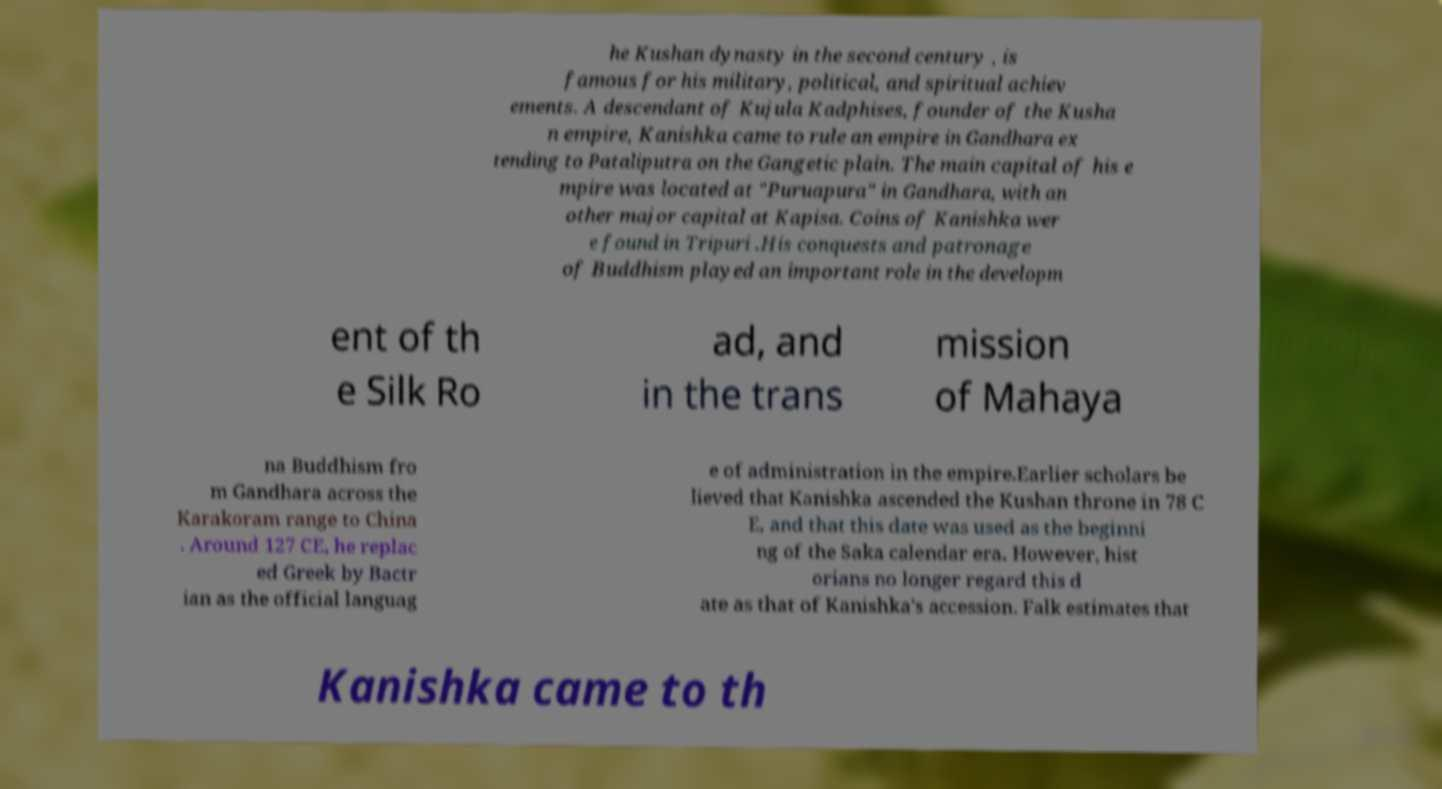Could you assist in decoding the text presented in this image and type it out clearly? he Kushan dynasty in the second century , is famous for his military, political, and spiritual achiev ements. A descendant of Kujula Kadphises, founder of the Kusha n empire, Kanishka came to rule an empire in Gandhara ex tending to Pataliputra on the Gangetic plain. The main capital of his e mpire was located at "Puruapura" in Gandhara, with an other major capital at Kapisa. Coins of Kanishka wer e found in Tripuri .His conquests and patronage of Buddhism played an important role in the developm ent of th e Silk Ro ad, and in the trans mission of Mahaya na Buddhism fro m Gandhara across the Karakoram range to China . Around 127 CE, he replac ed Greek by Bactr ian as the official languag e of administration in the empire.Earlier scholars be lieved that Kanishka ascended the Kushan throne in 78 C E, and that this date was used as the beginni ng of the Saka calendar era. However, hist orians no longer regard this d ate as that of Kanishka's accession. Falk estimates that Kanishka came to th 